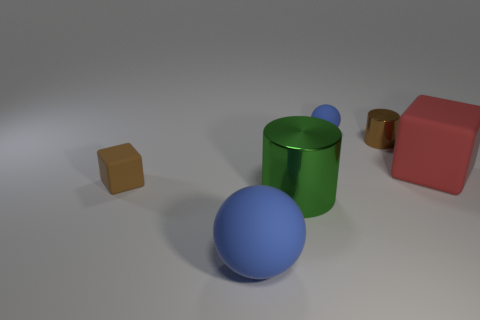What shape is the big rubber thing that is to the right of the tiny blue ball?
Your answer should be very brief. Cube. How many gray objects are shiny cylinders or rubber balls?
Provide a succinct answer. 0. Is the material of the large green cylinder the same as the tiny brown cylinder?
Your answer should be very brief. Yes. There is a large green shiny cylinder; what number of red cubes are to the right of it?
Offer a very short reply. 1. There is a large object that is to the left of the tiny sphere and behind the large blue matte thing; what material is it?
Provide a short and direct response. Metal. How many spheres are either brown metal objects or brown matte objects?
Keep it short and to the point. 0. What is the material of the brown object that is the same shape as the red rubber thing?
Your response must be concise. Rubber. There is another brown cube that is the same material as the big cube; what size is it?
Give a very brief answer. Small. Is the shape of the large rubber object in front of the tiny block the same as the large rubber object that is to the right of the tiny blue matte object?
Give a very brief answer. No. What is the color of the big thing that is made of the same material as the big sphere?
Offer a very short reply. Red. 